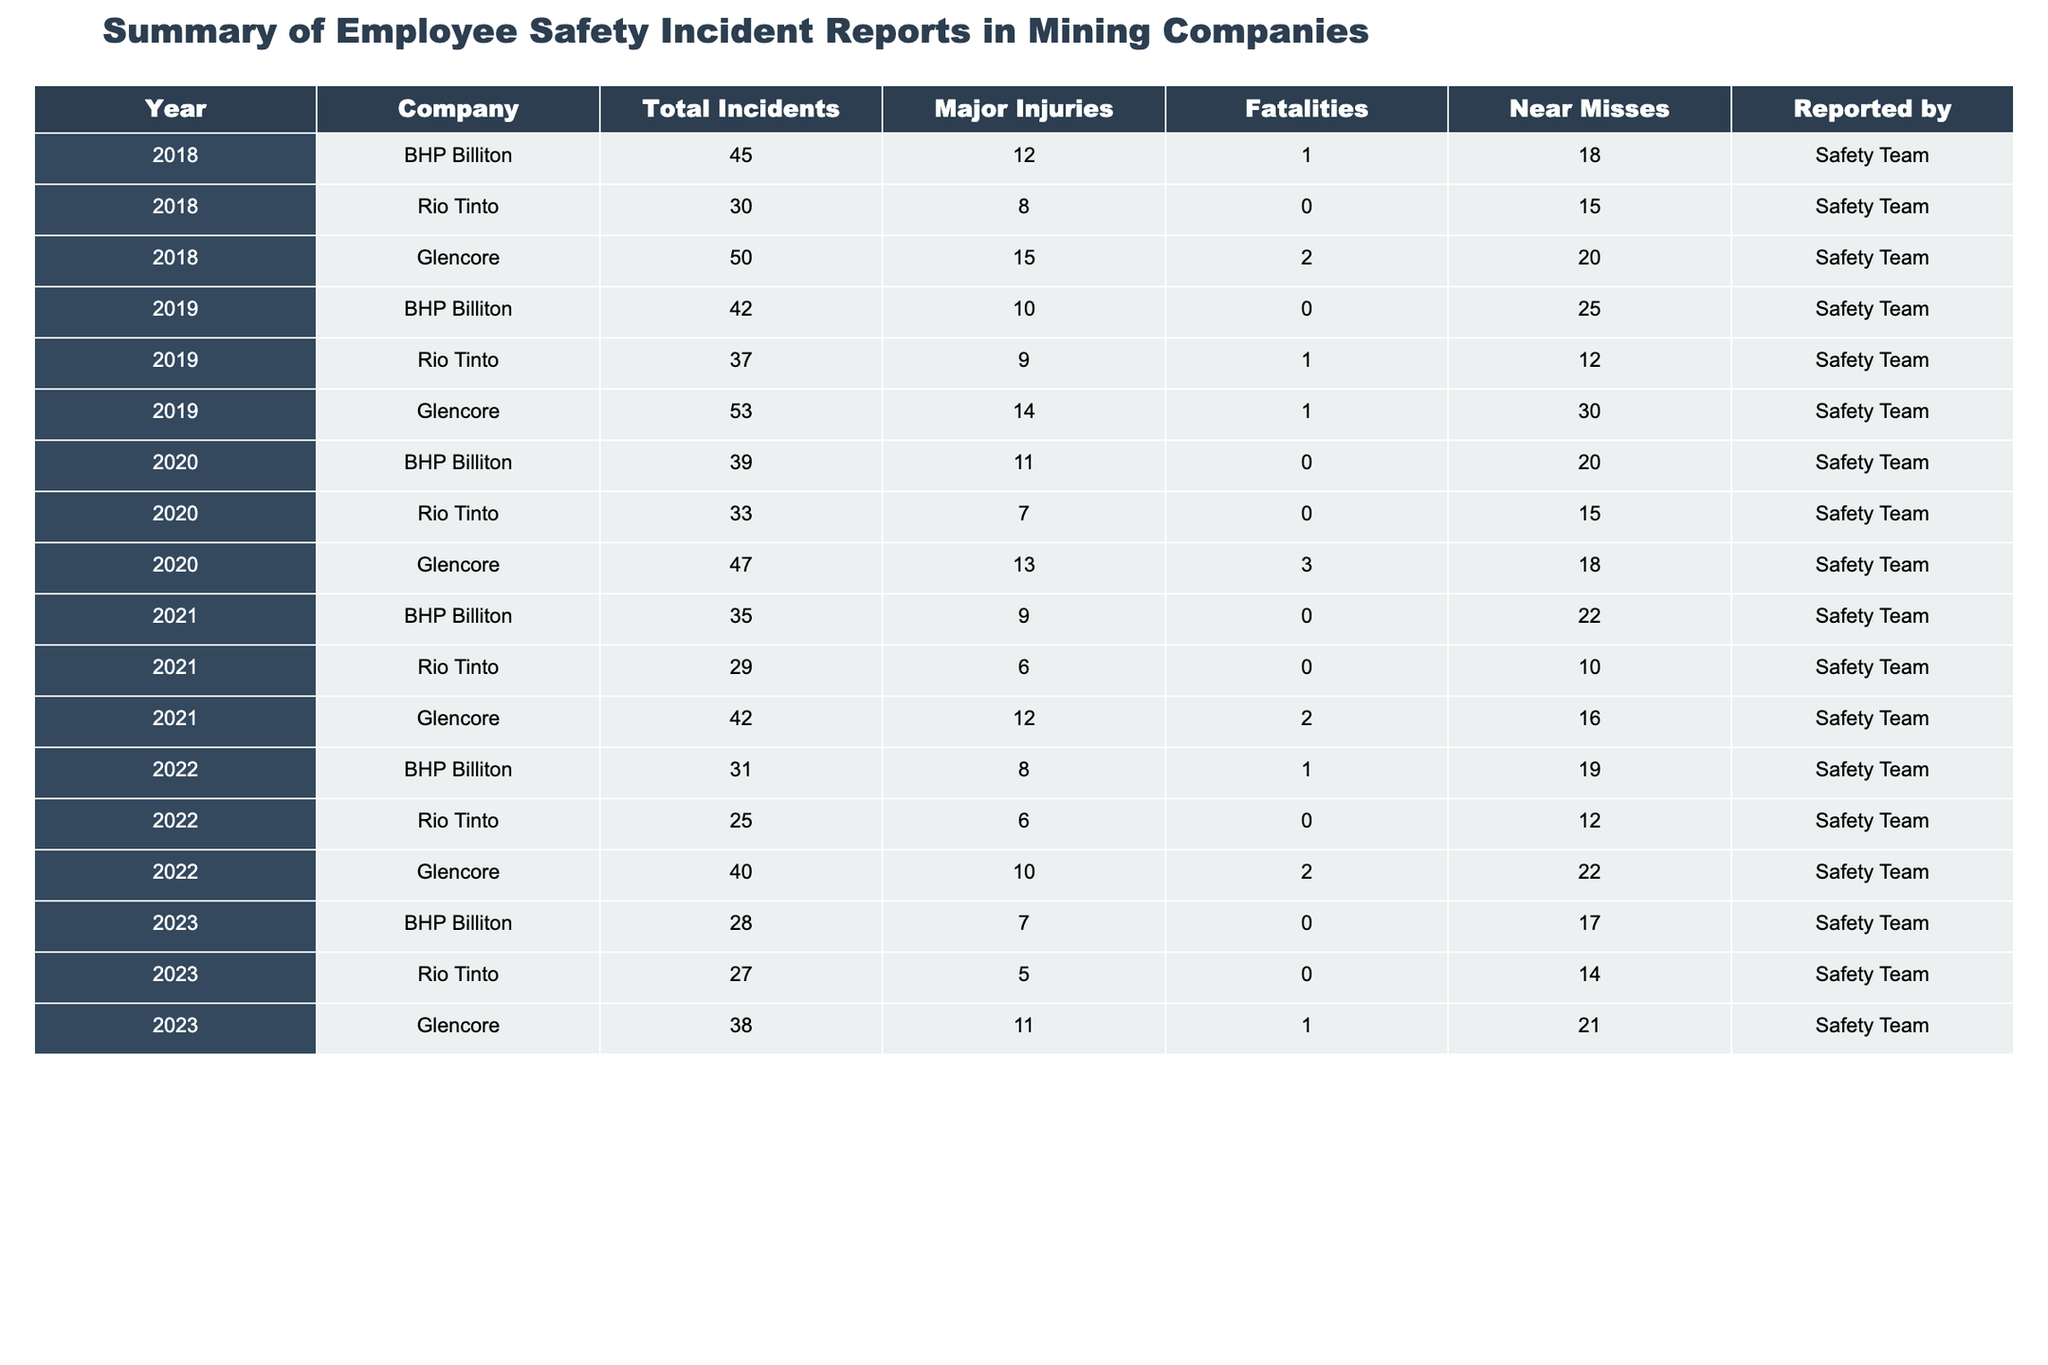What was the total number of fatalities reported by Glencore in 2020? Glencore reported 3 fatalities in 2020, as indicated in the table.
Answer: 3 In which year did BHP Billiton report the highest number of major injuries? Looking across the years in the table, BHP Billiton reported 12 major injuries in 2018, which is the highest compared to other years.
Answer: 2018 What is the total number of incidents reported by Rio Tinto from 2018 to 2023? Adding Rio Tinto's incidents for each year: 30 (2018) + 37 (2019) + 33 (2020) + 29 (2021) + 25 (2022) + 27 (2023) equals 181 total incidents.
Answer: 181 Did Glencore report any fatalities in 2021? The table shows that Glencore reported 2 fatalities in 2021.
Answer: Yes What is the average number of near misses reported by BHP Billiton from 2018 to 2023? BHP Billiton had near misses as follows: 18 (2018) + 25 (2019) + 20 (2020) + 22 (2021) + 19 (2022) + 17 (2023). The total is 121 near misses. Dividing by 6 gives an average of 20.17.
Answer: 20.17 Which company had the second highest total incidents in 2019? In 2019, BHP Billiton had 42 incidents, Rio Tinto had 37, and Glencore had the highest with 53. Therefore, Rio Tinto had the second highest.
Answer: Rio Tinto What is the difference in the number of fatalities reported by BHP Billiton between 2018 and 2022? In 2018, BHP Billiton had 1 fatality and in 2022 it also had 1 fatality, so the difference is 0.
Answer: 0 Which company consistently reported the least number of major injuries from 2018 to 2023? By examining the major injuries for all companies from 2018 to 2023, Rio Tinto reported the least number of major injuries (totaling 6 over the years), which is lower compared to BHP and Glencore.
Answer: Rio Tinto What was the year with the highest total incidents across all companies combined? Calculating total incidents per year across companies, 2019 shows the highest total incidents at 132 (42 + 37 + 53) compared to other years.
Answer: 2019 How many total major injuries were reported by all companies in 2020? Adding total major injuries reported in 2020: BHP Billiton (11) + Rio Tinto (7) + Glencore (13) gives a total of 31 major injuries for the year.
Answer: 31 Was there a year where BHP Billiton reported no fatalities at all? Yes, BHP Billiton reported no fatalities in 2019, 2020, 2021, 2022, and 2023, as seen in the table.
Answer: Yes 